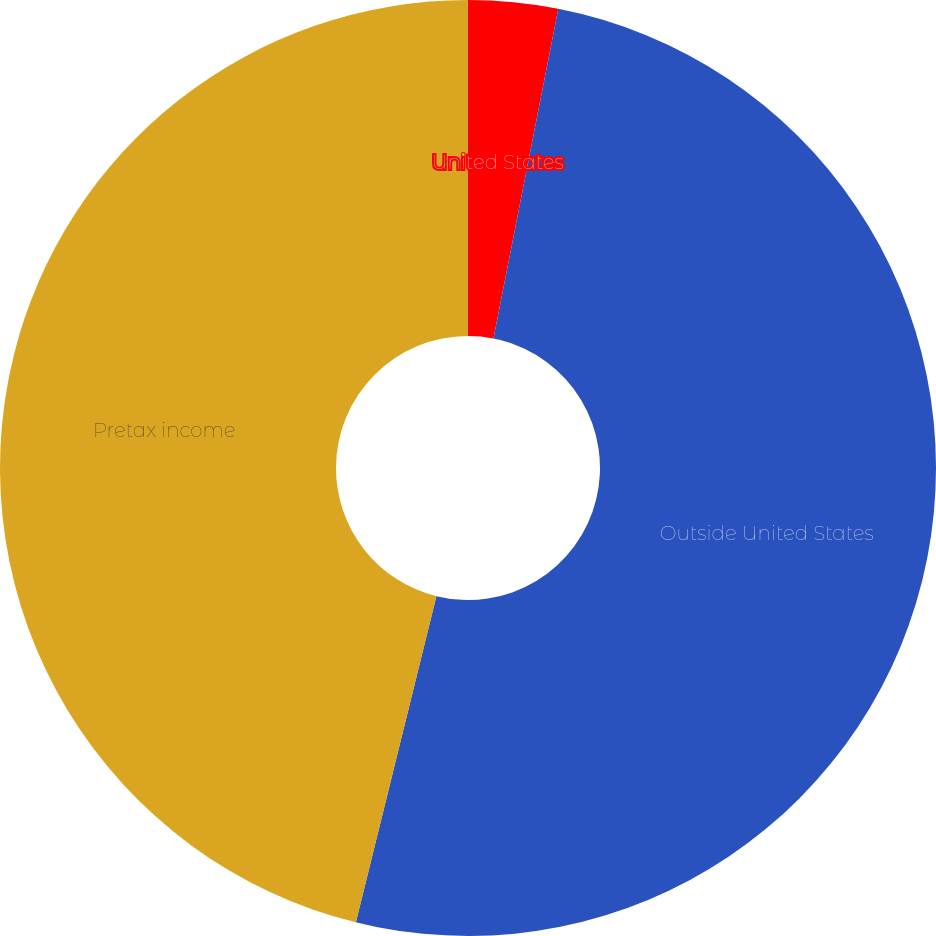Convert chart. <chart><loc_0><loc_0><loc_500><loc_500><pie_chart><fcel>United States<fcel>Outside United States<fcel>Pretax income<nl><fcel>3.09%<fcel>50.76%<fcel>46.15%<nl></chart> 